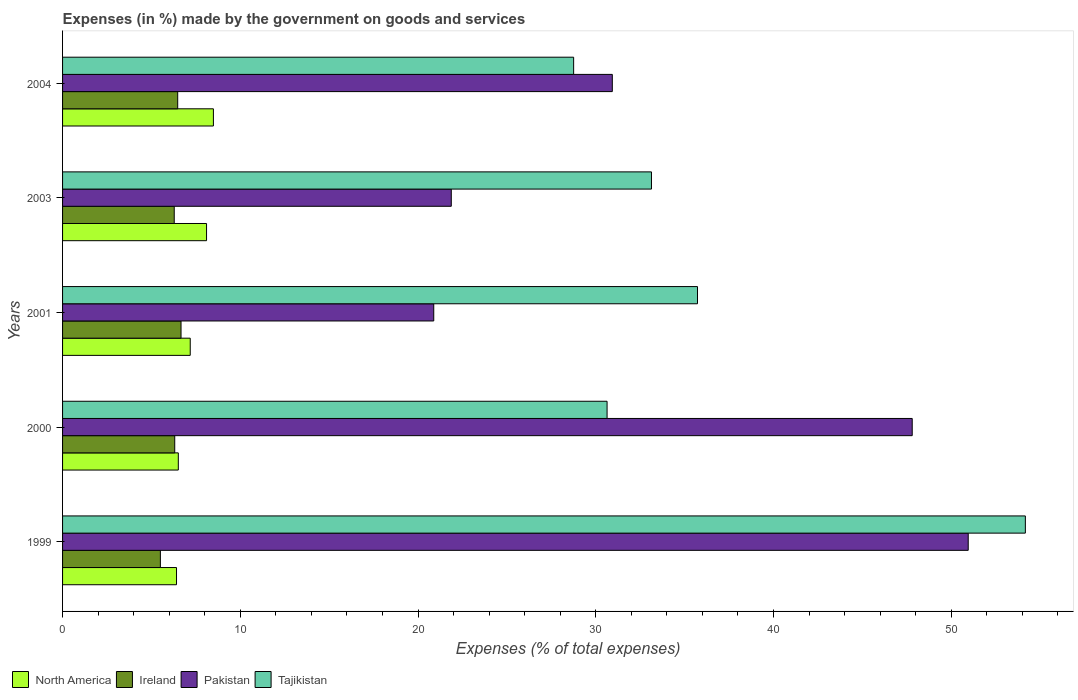How many groups of bars are there?
Offer a very short reply. 5. Are the number of bars per tick equal to the number of legend labels?
Your answer should be very brief. Yes. How many bars are there on the 4th tick from the top?
Your answer should be compact. 4. What is the percentage of expenses made by the government on goods and services in Tajikistan in 2001?
Make the answer very short. 35.72. Across all years, what is the maximum percentage of expenses made by the government on goods and services in Tajikistan?
Offer a terse response. 54.17. Across all years, what is the minimum percentage of expenses made by the government on goods and services in North America?
Make the answer very short. 6.41. In which year was the percentage of expenses made by the government on goods and services in Tajikistan maximum?
Offer a very short reply. 1999. In which year was the percentage of expenses made by the government on goods and services in Ireland minimum?
Your response must be concise. 1999. What is the total percentage of expenses made by the government on goods and services in North America in the graph?
Your answer should be very brief. 36.7. What is the difference between the percentage of expenses made by the government on goods and services in Tajikistan in 1999 and that in 2003?
Offer a very short reply. 21.04. What is the difference between the percentage of expenses made by the government on goods and services in Ireland in 2001 and the percentage of expenses made by the government on goods and services in Pakistan in 1999?
Keep it short and to the point. -44.29. What is the average percentage of expenses made by the government on goods and services in North America per year?
Ensure brevity in your answer.  7.34. In the year 2004, what is the difference between the percentage of expenses made by the government on goods and services in Pakistan and percentage of expenses made by the government on goods and services in North America?
Keep it short and to the point. 22.44. What is the ratio of the percentage of expenses made by the government on goods and services in Ireland in 2000 to that in 2001?
Your response must be concise. 0.95. Is the percentage of expenses made by the government on goods and services in North America in 2001 less than that in 2003?
Offer a terse response. Yes. Is the difference between the percentage of expenses made by the government on goods and services in Pakistan in 2001 and 2004 greater than the difference between the percentage of expenses made by the government on goods and services in North America in 2001 and 2004?
Offer a very short reply. No. What is the difference between the highest and the second highest percentage of expenses made by the government on goods and services in Tajikistan?
Your response must be concise. 18.45. What is the difference between the highest and the lowest percentage of expenses made by the government on goods and services in North America?
Offer a very short reply. 2.08. In how many years, is the percentage of expenses made by the government on goods and services in North America greater than the average percentage of expenses made by the government on goods and services in North America taken over all years?
Keep it short and to the point. 2. Is it the case that in every year, the sum of the percentage of expenses made by the government on goods and services in North America and percentage of expenses made by the government on goods and services in Tajikistan is greater than the sum of percentage of expenses made by the government on goods and services in Pakistan and percentage of expenses made by the government on goods and services in Ireland?
Ensure brevity in your answer.  Yes. What does the 1st bar from the top in 2001 represents?
Give a very brief answer. Tajikistan. How many bars are there?
Your answer should be compact. 20. Where does the legend appear in the graph?
Offer a terse response. Bottom left. What is the title of the graph?
Your answer should be compact. Expenses (in %) made by the government on goods and services. What is the label or title of the X-axis?
Keep it short and to the point. Expenses (% of total expenses). What is the Expenses (% of total expenses) in North America in 1999?
Offer a terse response. 6.41. What is the Expenses (% of total expenses) of Ireland in 1999?
Offer a very short reply. 5.5. What is the Expenses (% of total expenses) in Pakistan in 1999?
Your answer should be compact. 50.96. What is the Expenses (% of total expenses) in Tajikistan in 1999?
Offer a very short reply. 54.17. What is the Expenses (% of total expenses) in North America in 2000?
Your answer should be compact. 6.51. What is the Expenses (% of total expenses) in Ireland in 2000?
Offer a very short reply. 6.31. What is the Expenses (% of total expenses) of Pakistan in 2000?
Provide a succinct answer. 47.81. What is the Expenses (% of total expenses) in Tajikistan in 2000?
Make the answer very short. 30.64. What is the Expenses (% of total expenses) of North America in 2001?
Your response must be concise. 7.18. What is the Expenses (% of total expenses) in Ireland in 2001?
Offer a very short reply. 6.67. What is the Expenses (% of total expenses) in Pakistan in 2001?
Keep it short and to the point. 20.88. What is the Expenses (% of total expenses) of Tajikistan in 2001?
Ensure brevity in your answer.  35.72. What is the Expenses (% of total expenses) in North America in 2003?
Your answer should be very brief. 8.1. What is the Expenses (% of total expenses) of Ireland in 2003?
Your answer should be very brief. 6.28. What is the Expenses (% of total expenses) in Pakistan in 2003?
Ensure brevity in your answer.  21.87. What is the Expenses (% of total expenses) of Tajikistan in 2003?
Your answer should be very brief. 33.13. What is the Expenses (% of total expenses) of North America in 2004?
Offer a very short reply. 8.49. What is the Expenses (% of total expenses) in Ireland in 2004?
Your response must be concise. 6.48. What is the Expenses (% of total expenses) of Pakistan in 2004?
Your response must be concise. 30.93. What is the Expenses (% of total expenses) in Tajikistan in 2004?
Provide a short and direct response. 28.76. Across all years, what is the maximum Expenses (% of total expenses) in North America?
Give a very brief answer. 8.49. Across all years, what is the maximum Expenses (% of total expenses) of Ireland?
Keep it short and to the point. 6.67. Across all years, what is the maximum Expenses (% of total expenses) of Pakistan?
Give a very brief answer. 50.96. Across all years, what is the maximum Expenses (% of total expenses) in Tajikistan?
Ensure brevity in your answer.  54.17. Across all years, what is the minimum Expenses (% of total expenses) of North America?
Ensure brevity in your answer.  6.41. Across all years, what is the minimum Expenses (% of total expenses) of Ireland?
Give a very brief answer. 5.5. Across all years, what is the minimum Expenses (% of total expenses) of Pakistan?
Make the answer very short. 20.88. Across all years, what is the minimum Expenses (% of total expenses) of Tajikistan?
Provide a succinct answer. 28.76. What is the total Expenses (% of total expenses) in North America in the graph?
Provide a succinct answer. 36.7. What is the total Expenses (% of total expenses) of Ireland in the graph?
Ensure brevity in your answer.  31.24. What is the total Expenses (% of total expenses) in Pakistan in the graph?
Offer a terse response. 172.45. What is the total Expenses (% of total expenses) in Tajikistan in the graph?
Ensure brevity in your answer.  182.42. What is the difference between the Expenses (% of total expenses) of North America in 1999 and that in 2000?
Offer a terse response. -0.1. What is the difference between the Expenses (% of total expenses) in Ireland in 1999 and that in 2000?
Give a very brief answer. -0.81. What is the difference between the Expenses (% of total expenses) of Pakistan in 1999 and that in 2000?
Give a very brief answer. 3.15. What is the difference between the Expenses (% of total expenses) of Tajikistan in 1999 and that in 2000?
Keep it short and to the point. 23.53. What is the difference between the Expenses (% of total expenses) in North America in 1999 and that in 2001?
Make the answer very short. -0.77. What is the difference between the Expenses (% of total expenses) of Ireland in 1999 and that in 2001?
Keep it short and to the point. -1.16. What is the difference between the Expenses (% of total expenses) in Pakistan in 1999 and that in 2001?
Ensure brevity in your answer.  30.07. What is the difference between the Expenses (% of total expenses) of Tajikistan in 1999 and that in 2001?
Your answer should be compact. 18.45. What is the difference between the Expenses (% of total expenses) in North America in 1999 and that in 2003?
Provide a succinct answer. -1.69. What is the difference between the Expenses (% of total expenses) in Ireland in 1999 and that in 2003?
Keep it short and to the point. -0.78. What is the difference between the Expenses (% of total expenses) of Pakistan in 1999 and that in 2003?
Keep it short and to the point. 29.09. What is the difference between the Expenses (% of total expenses) of Tajikistan in 1999 and that in 2003?
Offer a terse response. 21.04. What is the difference between the Expenses (% of total expenses) in North America in 1999 and that in 2004?
Your answer should be compact. -2.08. What is the difference between the Expenses (% of total expenses) in Ireland in 1999 and that in 2004?
Your response must be concise. -0.97. What is the difference between the Expenses (% of total expenses) of Pakistan in 1999 and that in 2004?
Your answer should be compact. 20.03. What is the difference between the Expenses (% of total expenses) in Tajikistan in 1999 and that in 2004?
Offer a very short reply. 25.42. What is the difference between the Expenses (% of total expenses) of North America in 2000 and that in 2001?
Offer a terse response. -0.67. What is the difference between the Expenses (% of total expenses) in Ireland in 2000 and that in 2001?
Provide a succinct answer. -0.35. What is the difference between the Expenses (% of total expenses) in Pakistan in 2000 and that in 2001?
Make the answer very short. 26.92. What is the difference between the Expenses (% of total expenses) of Tajikistan in 2000 and that in 2001?
Offer a terse response. -5.09. What is the difference between the Expenses (% of total expenses) of North America in 2000 and that in 2003?
Your response must be concise. -1.59. What is the difference between the Expenses (% of total expenses) of Ireland in 2000 and that in 2003?
Offer a very short reply. 0.03. What is the difference between the Expenses (% of total expenses) in Pakistan in 2000 and that in 2003?
Your answer should be very brief. 25.93. What is the difference between the Expenses (% of total expenses) in Tajikistan in 2000 and that in 2003?
Provide a succinct answer. -2.5. What is the difference between the Expenses (% of total expenses) of North America in 2000 and that in 2004?
Offer a very short reply. -1.97. What is the difference between the Expenses (% of total expenses) of Ireland in 2000 and that in 2004?
Your answer should be very brief. -0.17. What is the difference between the Expenses (% of total expenses) in Pakistan in 2000 and that in 2004?
Offer a very short reply. 16.87. What is the difference between the Expenses (% of total expenses) in Tajikistan in 2000 and that in 2004?
Your response must be concise. 1.88. What is the difference between the Expenses (% of total expenses) of North America in 2001 and that in 2003?
Offer a terse response. -0.92. What is the difference between the Expenses (% of total expenses) in Ireland in 2001 and that in 2003?
Give a very brief answer. 0.38. What is the difference between the Expenses (% of total expenses) in Pakistan in 2001 and that in 2003?
Your answer should be compact. -0.99. What is the difference between the Expenses (% of total expenses) in Tajikistan in 2001 and that in 2003?
Ensure brevity in your answer.  2.59. What is the difference between the Expenses (% of total expenses) in North America in 2001 and that in 2004?
Offer a terse response. -1.3. What is the difference between the Expenses (% of total expenses) of Ireland in 2001 and that in 2004?
Ensure brevity in your answer.  0.19. What is the difference between the Expenses (% of total expenses) in Pakistan in 2001 and that in 2004?
Your response must be concise. -10.05. What is the difference between the Expenses (% of total expenses) of Tajikistan in 2001 and that in 2004?
Offer a very short reply. 6.97. What is the difference between the Expenses (% of total expenses) of North America in 2003 and that in 2004?
Your answer should be compact. -0.39. What is the difference between the Expenses (% of total expenses) of Ireland in 2003 and that in 2004?
Your response must be concise. -0.19. What is the difference between the Expenses (% of total expenses) of Pakistan in 2003 and that in 2004?
Your response must be concise. -9.06. What is the difference between the Expenses (% of total expenses) of Tajikistan in 2003 and that in 2004?
Ensure brevity in your answer.  4.38. What is the difference between the Expenses (% of total expenses) in North America in 1999 and the Expenses (% of total expenses) in Ireland in 2000?
Provide a succinct answer. 0.1. What is the difference between the Expenses (% of total expenses) of North America in 1999 and the Expenses (% of total expenses) of Pakistan in 2000?
Offer a terse response. -41.39. What is the difference between the Expenses (% of total expenses) of North America in 1999 and the Expenses (% of total expenses) of Tajikistan in 2000?
Offer a terse response. -24.23. What is the difference between the Expenses (% of total expenses) in Ireland in 1999 and the Expenses (% of total expenses) in Pakistan in 2000?
Ensure brevity in your answer.  -42.3. What is the difference between the Expenses (% of total expenses) of Ireland in 1999 and the Expenses (% of total expenses) of Tajikistan in 2000?
Give a very brief answer. -25.13. What is the difference between the Expenses (% of total expenses) in Pakistan in 1999 and the Expenses (% of total expenses) in Tajikistan in 2000?
Provide a succinct answer. 20.32. What is the difference between the Expenses (% of total expenses) in North America in 1999 and the Expenses (% of total expenses) in Ireland in 2001?
Ensure brevity in your answer.  -0.25. What is the difference between the Expenses (% of total expenses) in North America in 1999 and the Expenses (% of total expenses) in Pakistan in 2001?
Your response must be concise. -14.47. What is the difference between the Expenses (% of total expenses) of North America in 1999 and the Expenses (% of total expenses) of Tajikistan in 2001?
Offer a terse response. -29.31. What is the difference between the Expenses (% of total expenses) in Ireland in 1999 and the Expenses (% of total expenses) in Pakistan in 2001?
Offer a very short reply. -15.38. What is the difference between the Expenses (% of total expenses) of Ireland in 1999 and the Expenses (% of total expenses) of Tajikistan in 2001?
Your answer should be compact. -30.22. What is the difference between the Expenses (% of total expenses) in Pakistan in 1999 and the Expenses (% of total expenses) in Tajikistan in 2001?
Provide a short and direct response. 15.23. What is the difference between the Expenses (% of total expenses) in North America in 1999 and the Expenses (% of total expenses) in Ireland in 2003?
Make the answer very short. 0.13. What is the difference between the Expenses (% of total expenses) in North America in 1999 and the Expenses (% of total expenses) in Pakistan in 2003?
Offer a terse response. -15.46. What is the difference between the Expenses (% of total expenses) of North America in 1999 and the Expenses (% of total expenses) of Tajikistan in 2003?
Give a very brief answer. -26.72. What is the difference between the Expenses (% of total expenses) of Ireland in 1999 and the Expenses (% of total expenses) of Pakistan in 2003?
Ensure brevity in your answer.  -16.37. What is the difference between the Expenses (% of total expenses) in Ireland in 1999 and the Expenses (% of total expenses) in Tajikistan in 2003?
Offer a very short reply. -27.63. What is the difference between the Expenses (% of total expenses) of Pakistan in 1999 and the Expenses (% of total expenses) of Tajikistan in 2003?
Ensure brevity in your answer.  17.82. What is the difference between the Expenses (% of total expenses) in North America in 1999 and the Expenses (% of total expenses) in Ireland in 2004?
Offer a terse response. -0.07. What is the difference between the Expenses (% of total expenses) of North America in 1999 and the Expenses (% of total expenses) of Pakistan in 2004?
Offer a very short reply. -24.52. What is the difference between the Expenses (% of total expenses) in North America in 1999 and the Expenses (% of total expenses) in Tajikistan in 2004?
Ensure brevity in your answer.  -22.34. What is the difference between the Expenses (% of total expenses) in Ireland in 1999 and the Expenses (% of total expenses) in Pakistan in 2004?
Your response must be concise. -25.43. What is the difference between the Expenses (% of total expenses) in Ireland in 1999 and the Expenses (% of total expenses) in Tajikistan in 2004?
Offer a very short reply. -23.25. What is the difference between the Expenses (% of total expenses) of Pakistan in 1999 and the Expenses (% of total expenses) of Tajikistan in 2004?
Your answer should be very brief. 22.2. What is the difference between the Expenses (% of total expenses) of North America in 2000 and the Expenses (% of total expenses) of Ireland in 2001?
Your answer should be very brief. -0.15. What is the difference between the Expenses (% of total expenses) in North America in 2000 and the Expenses (% of total expenses) in Pakistan in 2001?
Ensure brevity in your answer.  -14.37. What is the difference between the Expenses (% of total expenses) in North America in 2000 and the Expenses (% of total expenses) in Tajikistan in 2001?
Your answer should be very brief. -29.21. What is the difference between the Expenses (% of total expenses) in Ireland in 2000 and the Expenses (% of total expenses) in Pakistan in 2001?
Keep it short and to the point. -14.57. What is the difference between the Expenses (% of total expenses) in Ireland in 2000 and the Expenses (% of total expenses) in Tajikistan in 2001?
Keep it short and to the point. -29.41. What is the difference between the Expenses (% of total expenses) of Pakistan in 2000 and the Expenses (% of total expenses) of Tajikistan in 2001?
Provide a short and direct response. 12.08. What is the difference between the Expenses (% of total expenses) of North America in 2000 and the Expenses (% of total expenses) of Ireland in 2003?
Provide a short and direct response. 0.23. What is the difference between the Expenses (% of total expenses) in North America in 2000 and the Expenses (% of total expenses) in Pakistan in 2003?
Give a very brief answer. -15.36. What is the difference between the Expenses (% of total expenses) in North America in 2000 and the Expenses (% of total expenses) in Tajikistan in 2003?
Keep it short and to the point. -26.62. What is the difference between the Expenses (% of total expenses) in Ireland in 2000 and the Expenses (% of total expenses) in Pakistan in 2003?
Provide a short and direct response. -15.56. What is the difference between the Expenses (% of total expenses) in Ireland in 2000 and the Expenses (% of total expenses) in Tajikistan in 2003?
Your response must be concise. -26.82. What is the difference between the Expenses (% of total expenses) of Pakistan in 2000 and the Expenses (% of total expenses) of Tajikistan in 2003?
Ensure brevity in your answer.  14.67. What is the difference between the Expenses (% of total expenses) in North America in 2000 and the Expenses (% of total expenses) in Ireland in 2004?
Your answer should be very brief. 0.03. What is the difference between the Expenses (% of total expenses) of North America in 2000 and the Expenses (% of total expenses) of Pakistan in 2004?
Ensure brevity in your answer.  -24.42. What is the difference between the Expenses (% of total expenses) of North America in 2000 and the Expenses (% of total expenses) of Tajikistan in 2004?
Keep it short and to the point. -22.24. What is the difference between the Expenses (% of total expenses) of Ireland in 2000 and the Expenses (% of total expenses) of Pakistan in 2004?
Keep it short and to the point. -24.62. What is the difference between the Expenses (% of total expenses) of Ireland in 2000 and the Expenses (% of total expenses) of Tajikistan in 2004?
Ensure brevity in your answer.  -22.44. What is the difference between the Expenses (% of total expenses) in Pakistan in 2000 and the Expenses (% of total expenses) in Tajikistan in 2004?
Give a very brief answer. 19.05. What is the difference between the Expenses (% of total expenses) in North America in 2001 and the Expenses (% of total expenses) in Ireland in 2003?
Your answer should be compact. 0.9. What is the difference between the Expenses (% of total expenses) in North America in 2001 and the Expenses (% of total expenses) in Pakistan in 2003?
Give a very brief answer. -14.69. What is the difference between the Expenses (% of total expenses) in North America in 2001 and the Expenses (% of total expenses) in Tajikistan in 2003?
Keep it short and to the point. -25.95. What is the difference between the Expenses (% of total expenses) in Ireland in 2001 and the Expenses (% of total expenses) in Pakistan in 2003?
Offer a terse response. -15.21. What is the difference between the Expenses (% of total expenses) in Ireland in 2001 and the Expenses (% of total expenses) in Tajikistan in 2003?
Your answer should be very brief. -26.47. What is the difference between the Expenses (% of total expenses) of Pakistan in 2001 and the Expenses (% of total expenses) of Tajikistan in 2003?
Your response must be concise. -12.25. What is the difference between the Expenses (% of total expenses) of North America in 2001 and the Expenses (% of total expenses) of Ireland in 2004?
Give a very brief answer. 0.7. What is the difference between the Expenses (% of total expenses) in North America in 2001 and the Expenses (% of total expenses) in Pakistan in 2004?
Provide a succinct answer. -23.75. What is the difference between the Expenses (% of total expenses) of North America in 2001 and the Expenses (% of total expenses) of Tajikistan in 2004?
Give a very brief answer. -21.57. What is the difference between the Expenses (% of total expenses) of Ireland in 2001 and the Expenses (% of total expenses) of Pakistan in 2004?
Your answer should be compact. -24.27. What is the difference between the Expenses (% of total expenses) of Ireland in 2001 and the Expenses (% of total expenses) of Tajikistan in 2004?
Your answer should be very brief. -22.09. What is the difference between the Expenses (% of total expenses) of Pakistan in 2001 and the Expenses (% of total expenses) of Tajikistan in 2004?
Provide a succinct answer. -7.87. What is the difference between the Expenses (% of total expenses) of North America in 2003 and the Expenses (% of total expenses) of Ireland in 2004?
Your response must be concise. 1.62. What is the difference between the Expenses (% of total expenses) in North America in 2003 and the Expenses (% of total expenses) in Pakistan in 2004?
Provide a succinct answer. -22.83. What is the difference between the Expenses (% of total expenses) of North America in 2003 and the Expenses (% of total expenses) of Tajikistan in 2004?
Your answer should be compact. -20.65. What is the difference between the Expenses (% of total expenses) of Ireland in 2003 and the Expenses (% of total expenses) of Pakistan in 2004?
Make the answer very short. -24.65. What is the difference between the Expenses (% of total expenses) in Ireland in 2003 and the Expenses (% of total expenses) in Tajikistan in 2004?
Your answer should be compact. -22.47. What is the difference between the Expenses (% of total expenses) of Pakistan in 2003 and the Expenses (% of total expenses) of Tajikistan in 2004?
Provide a succinct answer. -6.88. What is the average Expenses (% of total expenses) in North America per year?
Your response must be concise. 7.34. What is the average Expenses (% of total expenses) of Ireland per year?
Your answer should be very brief. 6.25. What is the average Expenses (% of total expenses) of Pakistan per year?
Offer a terse response. 34.49. What is the average Expenses (% of total expenses) of Tajikistan per year?
Keep it short and to the point. 36.48. In the year 1999, what is the difference between the Expenses (% of total expenses) in North America and Expenses (% of total expenses) in Ireland?
Keep it short and to the point. 0.91. In the year 1999, what is the difference between the Expenses (% of total expenses) of North America and Expenses (% of total expenses) of Pakistan?
Your answer should be compact. -44.55. In the year 1999, what is the difference between the Expenses (% of total expenses) in North America and Expenses (% of total expenses) in Tajikistan?
Keep it short and to the point. -47.76. In the year 1999, what is the difference between the Expenses (% of total expenses) of Ireland and Expenses (% of total expenses) of Pakistan?
Keep it short and to the point. -45.45. In the year 1999, what is the difference between the Expenses (% of total expenses) of Ireland and Expenses (% of total expenses) of Tajikistan?
Give a very brief answer. -48.67. In the year 1999, what is the difference between the Expenses (% of total expenses) of Pakistan and Expenses (% of total expenses) of Tajikistan?
Your answer should be very brief. -3.21. In the year 2000, what is the difference between the Expenses (% of total expenses) in North America and Expenses (% of total expenses) in Ireland?
Make the answer very short. 0.2. In the year 2000, what is the difference between the Expenses (% of total expenses) in North America and Expenses (% of total expenses) in Pakistan?
Provide a succinct answer. -41.29. In the year 2000, what is the difference between the Expenses (% of total expenses) of North America and Expenses (% of total expenses) of Tajikistan?
Ensure brevity in your answer.  -24.12. In the year 2000, what is the difference between the Expenses (% of total expenses) in Ireland and Expenses (% of total expenses) in Pakistan?
Offer a very short reply. -41.49. In the year 2000, what is the difference between the Expenses (% of total expenses) of Ireland and Expenses (% of total expenses) of Tajikistan?
Provide a short and direct response. -24.33. In the year 2000, what is the difference between the Expenses (% of total expenses) of Pakistan and Expenses (% of total expenses) of Tajikistan?
Your answer should be very brief. 17.17. In the year 2001, what is the difference between the Expenses (% of total expenses) in North America and Expenses (% of total expenses) in Ireland?
Make the answer very short. 0.52. In the year 2001, what is the difference between the Expenses (% of total expenses) of North America and Expenses (% of total expenses) of Pakistan?
Ensure brevity in your answer.  -13.7. In the year 2001, what is the difference between the Expenses (% of total expenses) in North America and Expenses (% of total expenses) in Tajikistan?
Make the answer very short. -28.54. In the year 2001, what is the difference between the Expenses (% of total expenses) of Ireland and Expenses (% of total expenses) of Pakistan?
Make the answer very short. -14.22. In the year 2001, what is the difference between the Expenses (% of total expenses) of Ireland and Expenses (% of total expenses) of Tajikistan?
Your answer should be very brief. -29.06. In the year 2001, what is the difference between the Expenses (% of total expenses) of Pakistan and Expenses (% of total expenses) of Tajikistan?
Give a very brief answer. -14.84. In the year 2003, what is the difference between the Expenses (% of total expenses) of North America and Expenses (% of total expenses) of Ireland?
Keep it short and to the point. 1.82. In the year 2003, what is the difference between the Expenses (% of total expenses) in North America and Expenses (% of total expenses) in Pakistan?
Give a very brief answer. -13.77. In the year 2003, what is the difference between the Expenses (% of total expenses) in North America and Expenses (% of total expenses) in Tajikistan?
Provide a short and direct response. -25.03. In the year 2003, what is the difference between the Expenses (% of total expenses) of Ireland and Expenses (% of total expenses) of Pakistan?
Keep it short and to the point. -15.59. In the year 2003, what is the difference between the Expenses (% of total expenses) of Ireland and Expenses (% of total expenses) of Tajikistan?
Make the answer very short. -26.85. In the year 2003, what is the difference between the Expenses (% of total expenses) of Pakistan and Expenses (% of total expenses) of Tajikistan?
Your answer should be compact. -11.26. In the year 2004, what is the difference between the Expenses (% of total expenses) of North America and Expenses (% of total expenses) of Ireland?
Give a very brief answer. 2.01. In the year 2004, what is the difference between the Expenses (% of total expenses) in North America and Expenses (% of total expenses) in Pakistan?
Your answer should be compact. -22.44. In the year 2004, what is the difference between the Expenses (% of total expenses) in North America and Expenses (% of total expenses) in Tajikistan?
Ensure brevity in your answer.  -20.27. In the year 2004, what is the difference between the Expenses (% of total expenses) of Ireland and Expenses (% of total expenses) of Pakistan?
Provide a short and direct response. -24.45. In the year 2004, what is the difference between the Expenses (% of total expenses) of Ireland and Expenses (% of total expenses) of Tajikistan?
Your response must be concise. -22.28. In the year 2004, what is the difference between the Expenses (% of total expenses) of Pakistan and Expenses (% of total expenses) of Tajikistan?
Your answer should be very brief. 2.18. What is the ratio of the Expenses (% of total expenses) of North America in 1999 to that in 2000?
Provide a short and direct response. 0.98. What is the ratio of the Expenses (% of total expenses) in Ireland in 1999 to that in 2000?
Give a very brief answer. 0.87. What is the ratio of the Expenses (% of total expenses) in Pakistan in 1999 to that in 2000?
Keep it short and to the point. 1.07. What is the ratio of the Expenses (% of total expenses) of Tajikistan in 1999 to that in 2000?
Give a very brief answer. 1.77. What is the ratio of the Expenses (% of total expenses) of North America in 1999 to that in 2001?
Provide a short and direct response. 0.89. What is the ratio of the Expenses (% of total expenses) in Ireland in 1999 to that in 2001?
Provide a short and direct response. 0.83. What is the ratio of the Expenses (% of total expenses) of Pakistan in 1999 to that in 2001?
Give a very brief answer. 2.44. What is the ratio of the Expenses (% of total expenses) of Tajikistan in 1999 to that in 2001?
Offer a terse response. 1.52. What is the ratio of the Expenses (% of total expenses) in North America in 1999 to that in 2003?
Your answer should be very brief. 0.79. What is the ratio of the Expenses (% of total expenses) of Ireland in 1999 to that in 2003?
Provide a short and direct response. 0.88. What is the ratio of the Expenses (% of total expenses) in Pakistan in 1999 to that in 2003?
Your response must be concise. 2.33. What is the ratio of the Expenses (% of total expenses) of Tajikistan in 1999 to that in 2003?
Offer a terse response. 1.63. What is the ratio of the Expenses (% of total expenses) in North America in 1999 to that in 2004?
Keep it short and to the point. 0.76. What is the ratio of the Expenses (% of total expenses) of Ireland in 1999 to that in 2004?
Offer a very short reply. 0.85. What is the ratio of the Expenses (% of total expenses) of Pakistan in 1999 to that in 2004?
Give a very brief answer. 1.65. What is the ratio of the Expenses (% of total expenses) of Tajikistan in 1999 to that in 2004?
Provide a short and direct response. 1.88. What is the ratio of the Expenses (% of total expenses) in North America in 2000 to that in 2001?
Provide a succinct answer. 0.91. What is the ratio of the Expenses (% of total expenses) of Ireland in 2000 to that in 2001?
Provide a succinct answer. 0.95. What is the ratio of the Expenses (% of total expenses) of Pakistan in 2000 to that in 2001?
Provide a succinct answer. 2.29. What is the ratio of the Expenses (% of total expenses) in Tajikistan in 2000 to that in 2001?
Your response must be concise. 0.86. What is the ratio of the Expenses (% of total expenses) of North America in 2000 to that in 2003?
Provide a short and direct response. 0.8. What is the ratio of the Expenses (% of total expenses) in Ireland in 2000 to that in 2003?
Your answer should be compact. 1. What is the ratio of the Expenses (% of total expenses) of Pakistan in 2000 to that in 2003?
Your response must be concise. 2.19. What is the ratio of the Expenses (% of total expenses) in Tajikistan in 2000 to that in 2003?
Make the answer very short. 0.92. What is the ratio of the Expenses (% of total expenses) of North America in 2000 to that in 2004?
Provide a succinct answer. 0.77. What is the ratio of the Expenses (% of total expenses) in Ireland in 2000 to that in 2004?
Keep it short and to the point. 0.97. What is the ratio of the Expenses (% of total expenses) in Pakistan in 2000 to that in 2004?
Provide a succinct answer. 1.55. What is the ratio of the Expenses (% of total expenses) in Tajikistan in 2000 to that in 2004?
Keep it short and to the point. 1.07. What is the ratio of the Expenses (% of total expenses) in North America in 2001 to that in 2003?
Provide a short and direct response. 0.89. What is the ratio of the Expenses (% of total expenses) in Ireland in 2001 to that in 2003?
Provide a succinct answer. 1.06. What is the ratio of the Expenses (% of total expenses) of Pakistan in 2001 to that in 2003?
Offer a terse response. 0.95. What is the ratio of the Expenses (% of total expenses) of Tajikistan in 2001 to that in 2003?
Provide a succinct answer. 1.08. What is the ratio of the Expenses (% of total expenses) of North America in 2001 to that in 2004?
Keep it short and to the point. 0.85. What is the ratio of the Expenses (% of total expenses) of Ireland in 2001 to that in 2004?
Ensure brevity in your answer.  1.03. What is the ratio of the Expenses (% of total expenses) of Pakistan in 2001 to that in 2004?
Keep it short and to the point. 0.68. What is the ratio of the Expenses (% of total expenses) in Tajikistan in 2001 to that in 2004?
Make the answer very short. 1.24. What is the ratio of the Expenses (% of total expenses) of North America in 2003 to that in 2004?
Your answer should be very brief. 0.95. What is the ratio of the Expenses (% of total expenses) of Ireland in 2003 to that in 2004?
Provide a succinct answer. 0.97. What is the ratio of the Expenses (% of total expenses) of Pakistan in 2003 to that in 2004?
Offer a very short reply. 0.71. What is the ratio of the Expenses (% of total expenses) of Tajikistan in 2003 to that in 2004?
Provide a short and direct response. 1.15. What is the difference between the highest and the second highest Expenses (% of total expenses) of North America?
Give a very brief answer. 0.39. What is the difference between the highest and the second highest Expenses (% of total expenses) in Ireland?
Offer a terse response. 0.19. What is the difference between the highest and the second highest Expenses (% of total expenses) of Pakistan?
Your answer should be very brief. 3.15. What is the difference between the highest and the second highest Expenses (% of total expenses) in Tajikistan?
Give a very brief answer. 18.45. What is the difference between the highest and the lowest Expenses (% of total expenses) in North America?
Give a very brief answer. 2.08. What is the difference between the highest and the lowest Expenses (% of total expenses) in Ireland?
Offer a terse response. 1.16. What is the difference between the highest and the lowest Expenses (% of total expenses) of Pakistan?
Give a very brief answer. 30.07. What is the difference between the highest and the lowest Expenses (% of total expenses) of Tajikistan?
Offer a terse response. 25.42. 